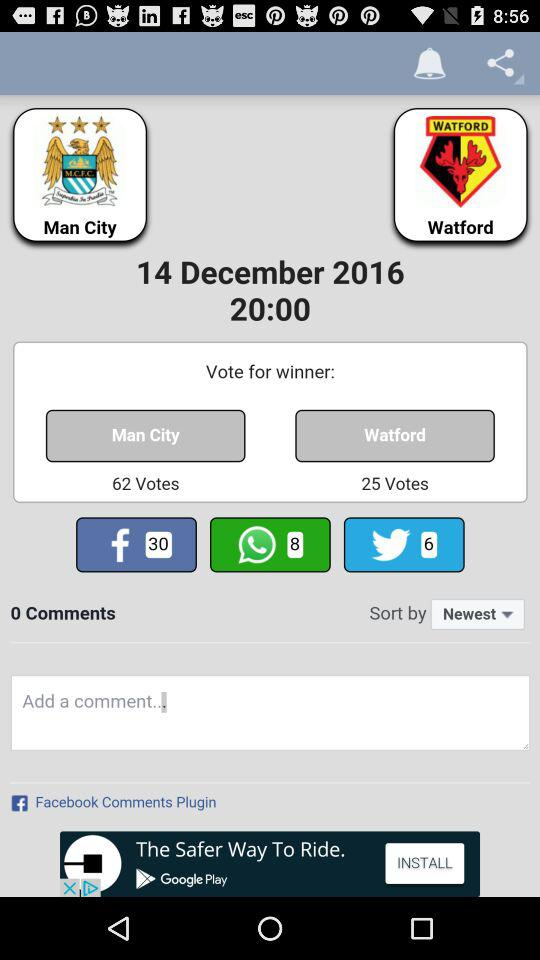How many comments are there? There are 0 comments. 